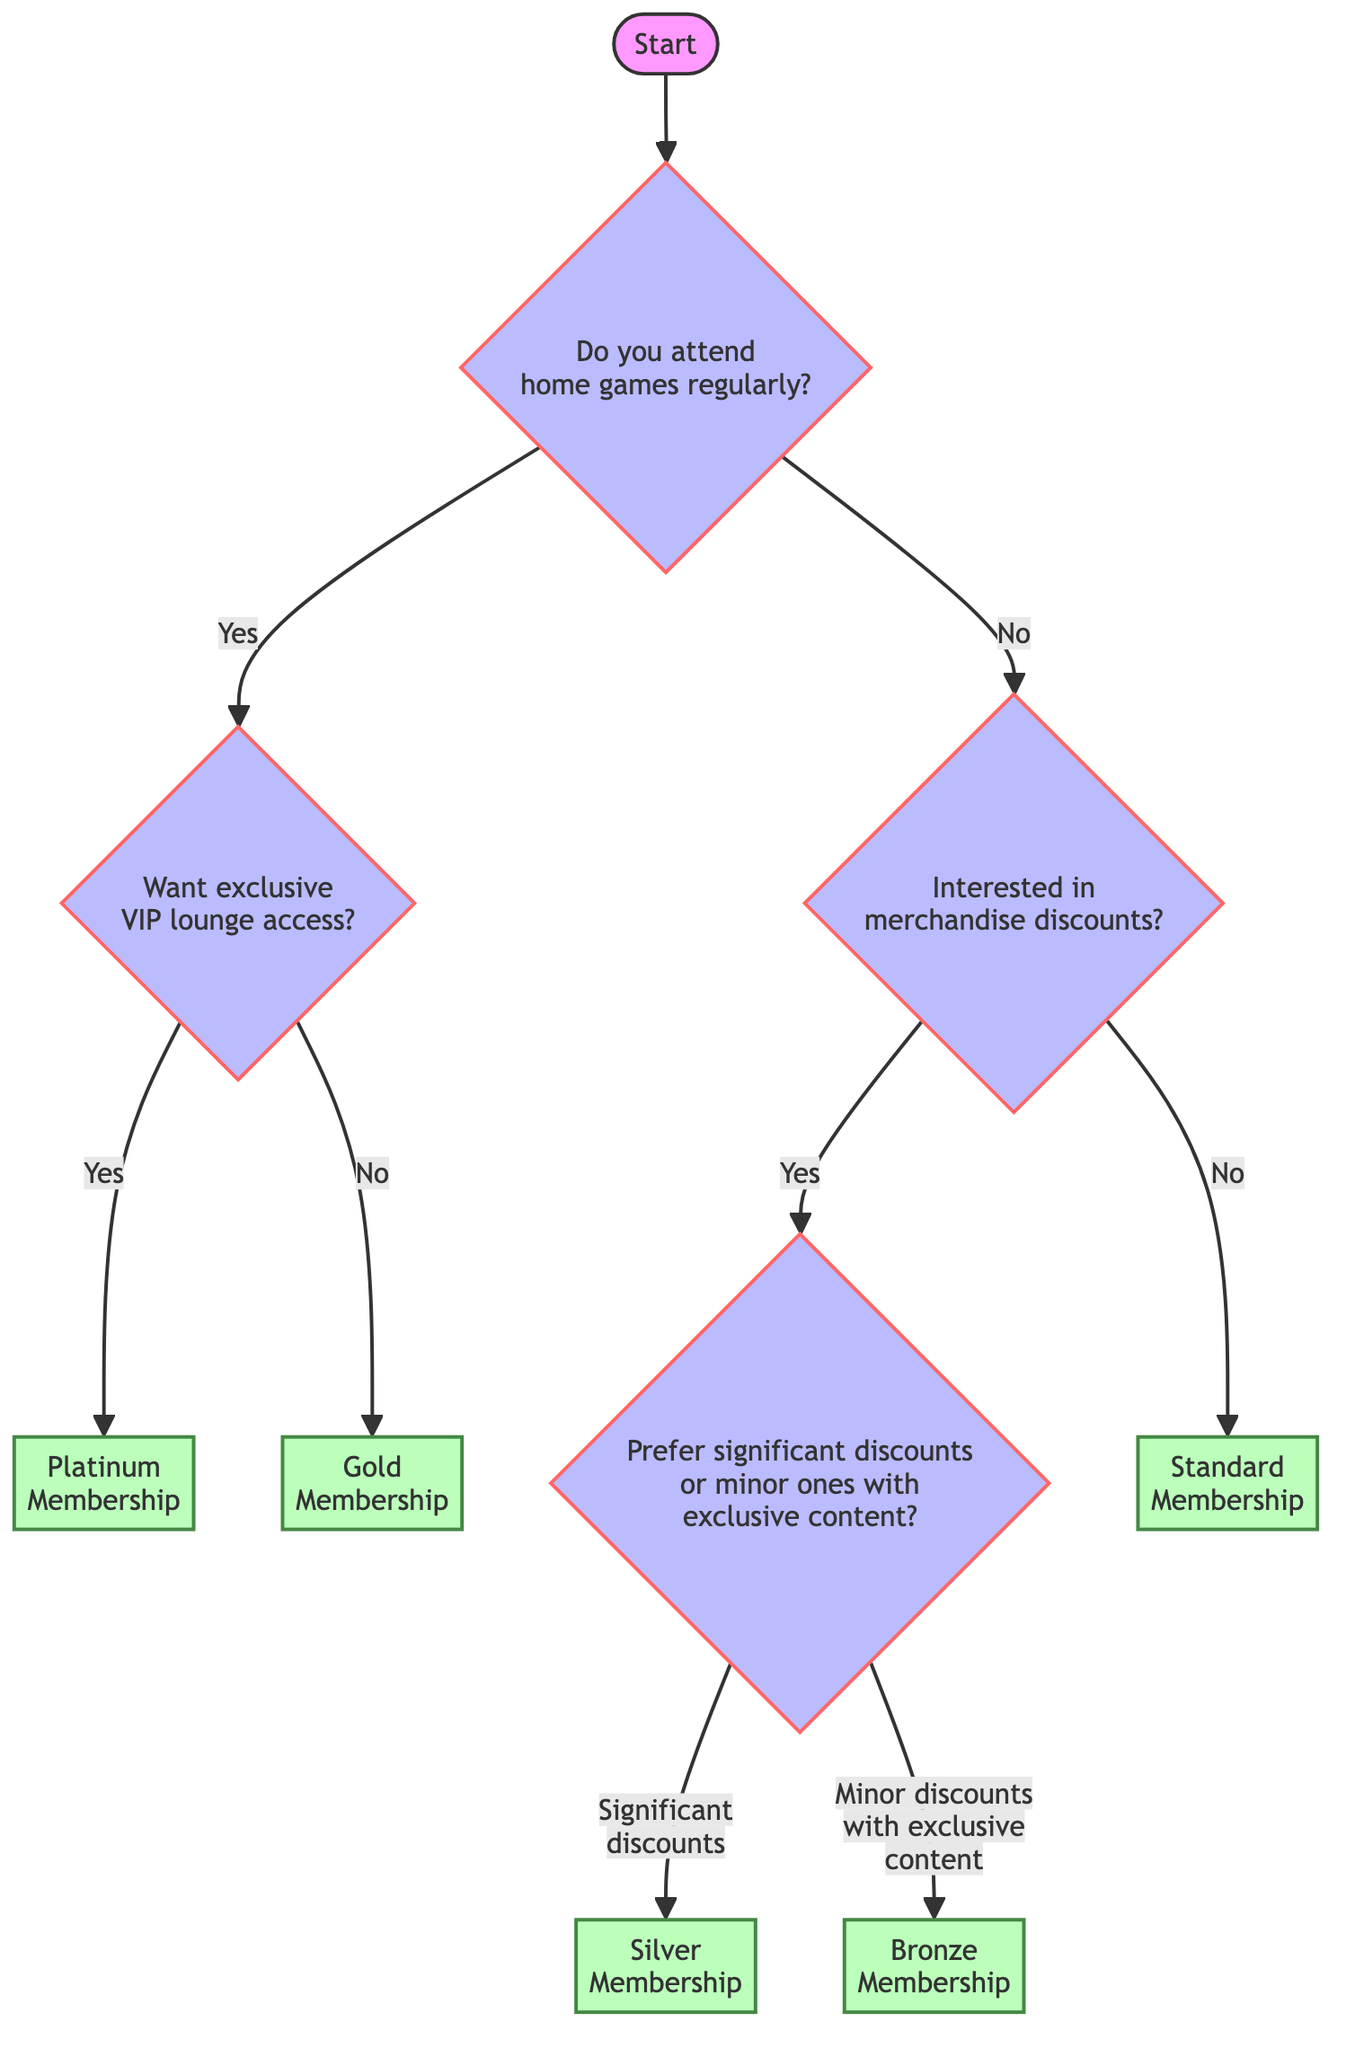What's the root question of the decision tree? The root question of the decision tree is "Do you attend home games regularly?" which is the first decision point in the diagram.
Answer: Do you attend home games regularly? What are the two possible responses to the root question? The two possible responses to the root question are "Yes" and "No", leading to different branches in the decision tree.
Answer: Yes and No If you answer "No" to the root question, what is the next question asked? If the answer is "No," the next question asked is "Are you interested in official merchandise discounts?" which is the first decision point for those who do not attend games.
Answer: Are you interested in official merchandise discounts? What membership do you get if you attend home games regularly and want exclusive access to VIP lounges? If you attend home games regularly and want exclusive access to VIP lounges, you will get the "Platinum Membership," which is the outcome of that decision pathway.
Answer: Platinum Membership If you are not interested in merchandise discounts, what membership do you end up with? If you are not interested in merchandise discounts, you directly end up with the "Standard Membership," which is the outcome for that branch of the decision tree.
Answer: Standard Membership What result do you get if you want significant discounts on merchandise? If you want significant discounts on merchandise, the result you get is the "Silver Membership," which is reached by following the specific path in the decision tree.
Answer: Silver Membership How many total memberships are possible from this decision tree? There are a total of five memberships possible from this decision tree: Platinum Membership, Gold Membership, Silver Membership, Bronze Membership, and Standard Membership, which are the final results in different branches.
Answer: Five What is the deciding factor for receiving a Bronze Membership instead of a Silver Membership? The deciding factor for receiving a Bronze Membership instead of a Silver Membership is the choice between "minor discounts with more exclusive content" versus "significant discounts." Choosing the former leads to a Bronze Membership.
Answer: Minor discounts with more exclusive content 